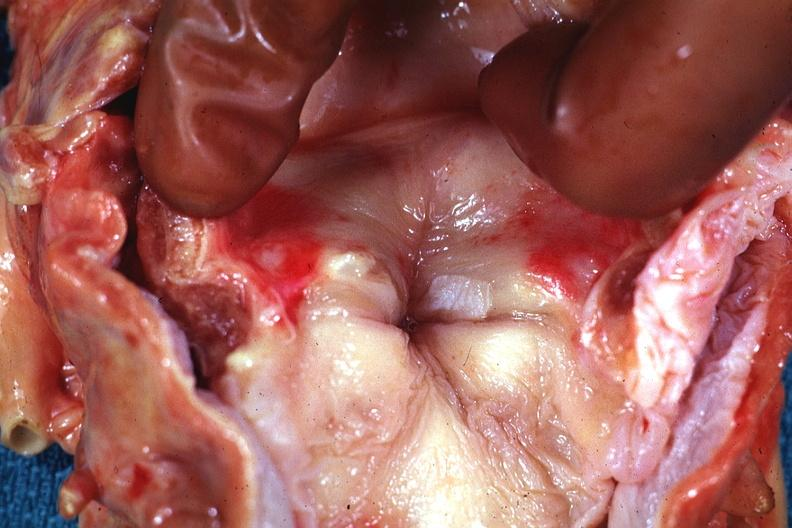what is present?
Answer the question using a single word or phrase. Oral 